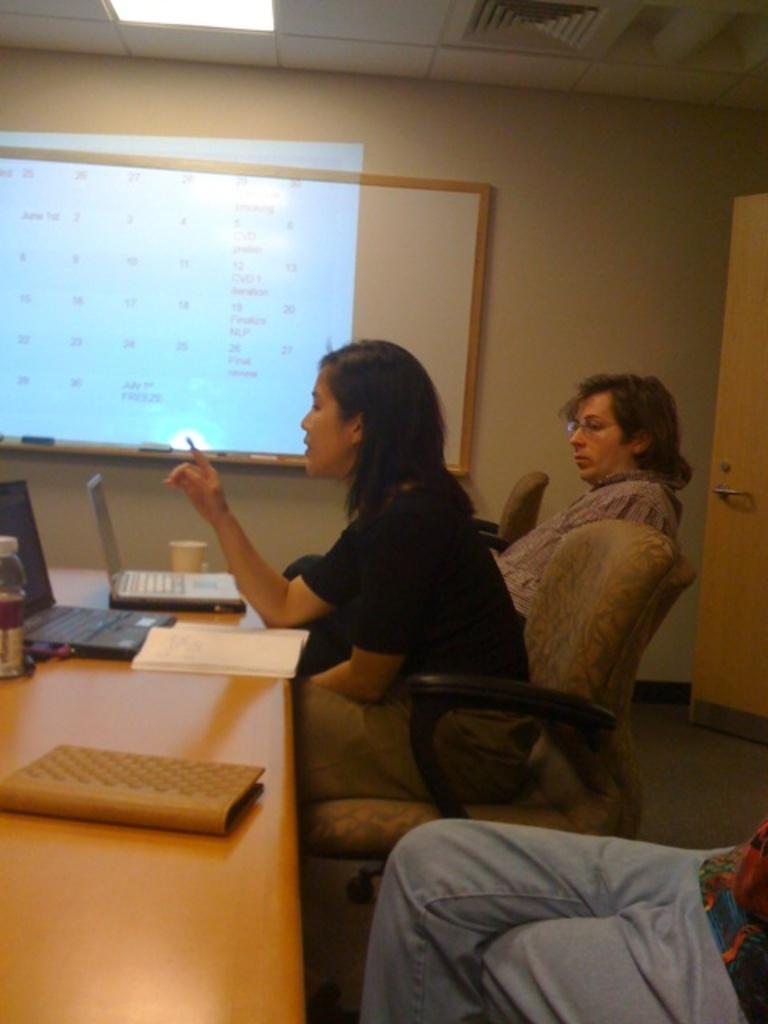How would you summarize this image in a sentence or two? This picture shows three people seated on the chairs and a women speaking and we see laptops papers and books and a water bottle on the table and we see whiteboard and projection light on it 